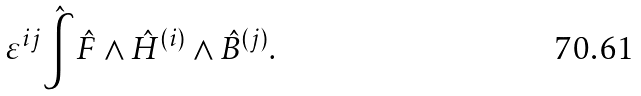Convert formula to latex. <formula><loc_0><loc_0><loc_500><loc_500>\varepsilon ^ { i j } \hat { \int } \hat { F } \wedge \hat { H } ^ { ( i ) } \wedge \hat { B } ^ { ( j ) } .</formula> 